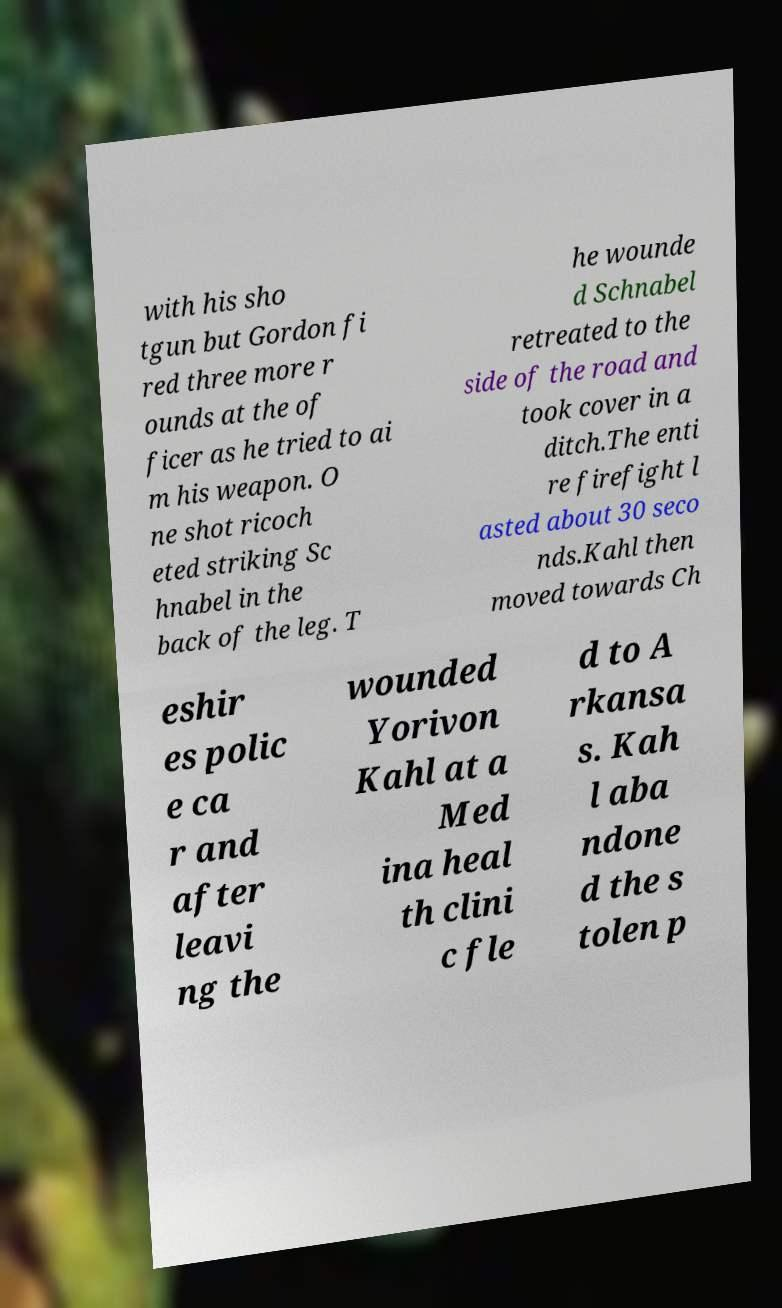Please read and relay the text visible in this image. What does it say? with his sho tgun but Gordon fi red three more r ounds at the of ficer as he tried to ai m his weapon. O ne shot ricoch eted striking Sc hnabel in the back of the leg. T he wounde d Schnabel retreated to the side of the road and took cover in a ditch.The enti re firefight l asted about 30 seco nds.Kahl then moved towards Ch eshir es polic e ca r and after leavi ng the wounded Yorivon Kahl at a Med ina heal th clini c fle d to A rkansa s. Kah l aba ndone d the s tolen p 